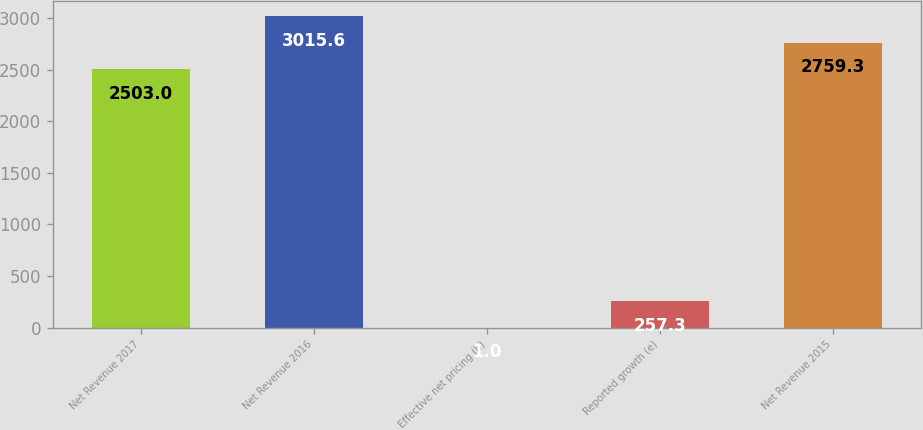Convert chart. <chart><loc_0><loc_0><loc_500><loc_500><bar_chart><fcel>Net Revenue 2017<fcel>Net Revenue 2016<fcel>Effective net pricing (b)<fcel>Reported growth (e)<fcel>Net Revenue 2015<nl><fcel>2503<fcel>3015.6<fcel>1<fcel>257.3<fcel>2759.3<nl></chart> 